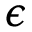Convert formula to latex. <formula><loc_0><loc_0><loc_500><loc_500>\epsilon</formula> 